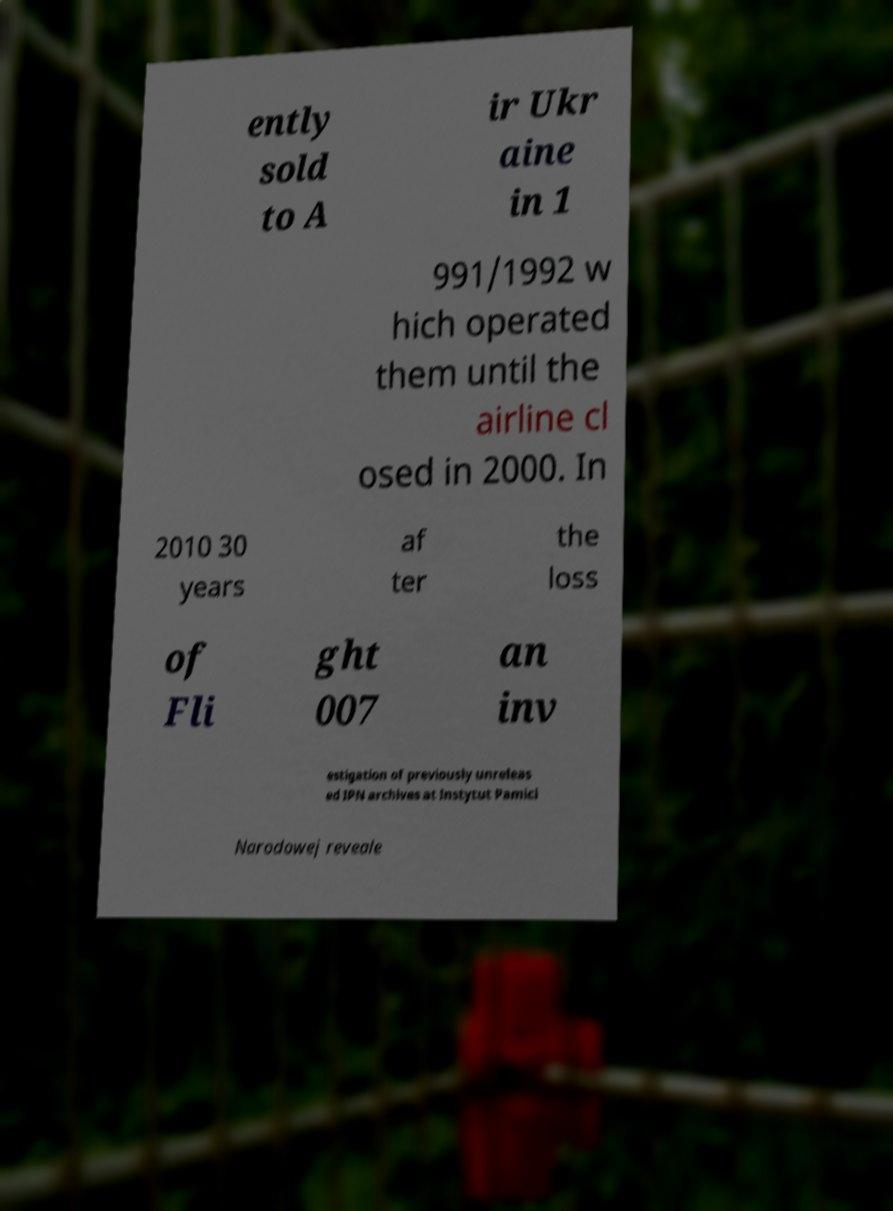What messages or text are displayed in this image? I need them in a readable, typed format. ently sold to A ir Ukr aine in 1 991/1992 w hich operated them until the airline cl osed in 2000. In 2010 30 years af ter the loss of Fli ght 007 an inv estigation of previously unreleas ed IPN archives at Instytut Pamici Narodowej reveale 